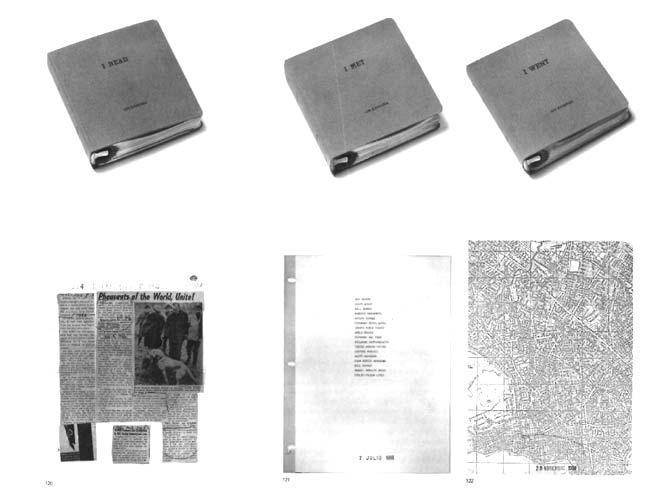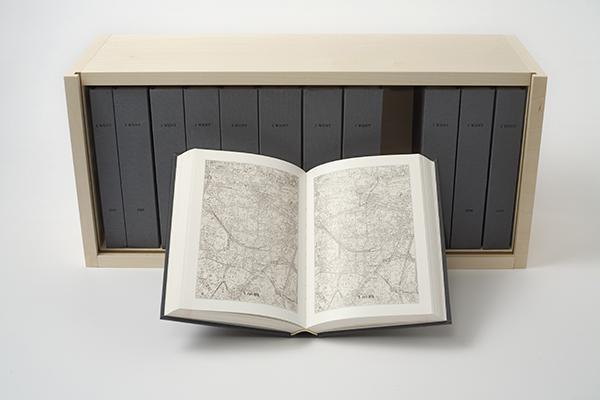The first image is the image on the left, the second image is the image on the right. For the images shown, is this caption "There are two binders in total." true? Answer yes or no. No. The first image is the image on the left, the second image is the image on the right. Considering the images on both sides, is "Exactly two ring binder notebooks with plastic cover, each a different color, are standing on end, at least one of them empty." valid? Answer yes or no. No. 